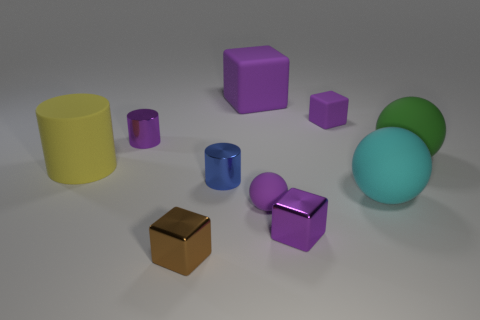Are any metallic spheres visible?
Ensure brevity in your answer.  No. What is the shape of the object on the left side of the purple shiny object behind the tiny blue metallic cylinder?
Give a very brief answer. Cylinder. What number of objects are either purple rubber objects or big things that are to the right of the brown cube?
Give a very brief answer. 5. What color is the block on the left side of the large rubber thing behind the small metal object that is behind the green rubber ball?
Keep it short and to the point. Brown. There is another big object that is the same shape as the brown metal object; what is its material?
Keep it short and to the point. Rubber. The tiny matte block is what color?
Provide a succinct answer. Purple. Is the matte cylinder the same color as the tiny rubber cube?
Your answer should be very brief. No. How many rubber things are spheres or small purple cubes?
Your answer should be very brief. 4. There is a large rubber ball that is in front of the rubber sphere that is behind the big cyan matte object; are there any balls behind it?
Provide a short and direct response. Yes. There is another cylinder that is made of the same material as the purple cylinder; what is its size?
Ensure brevity in your answer.  Small. 